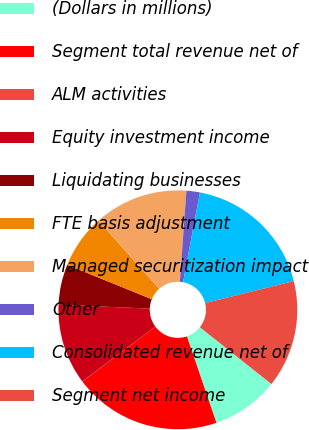<chart> <loc_0><loc_0><loc_500><loc_500><pie_chart><fcel>(Dollars in millions)<fcel>Segment total revenue net of<fcel>ALM activities<fcel>Equity investment income<fcel>Liquidating businesses<fcel>FTE basis adjustment<fcel>Managed securitization impact<fcel>Other<fcel>Consolidated revenue net of<fcel>Segment net income<nl><fcel>9.09%<fcel>19.98%<fcel>0.02%<fcel>10.91%<fcel>5.46%<fcel>7.28%<fcel>12.72%<fcel>1.83%<fcel>18.17%<fcel>14.54%<nl></chart> 